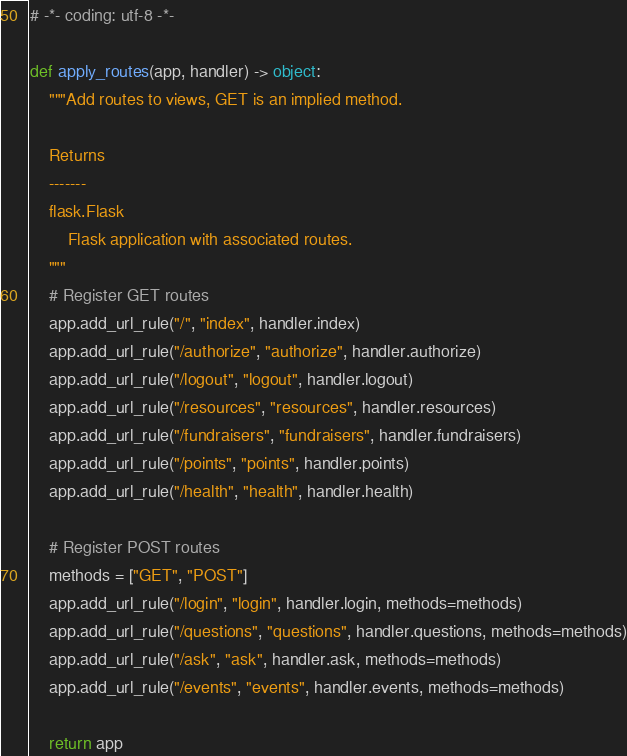<code> <loc_0><loc_0><loc_500><loc_500><_Python_># -*- coding: utf-8 -*-

def apply_routes(app, handler) -> object:
	"""Add routes to views, GET is an implied method.
	
	Returns
	-------
	flask.Flask
		Flask application with associated routes.
	"""
	# Register GET routes
	app.add_url_rule("/", "index", handler.index)
	app.add_url_rule("/authorize", "authorize", handler.authorize)
	app.add_url_rule("/logout", "logout", handler.logout)
	app.add_url_rule("/resources", "resources", handler.resources)
	app.add_url_rule("/fundraisers", "fundraisers", handler.fundraisers)
	app.add_url_rule("/points", "points", handler.points)
	app.add_url_rule("/health", "health", handler.health)

	# Register POST routes
	methods = ["GET", "POST"]
	app.add_url_rule("/login", "login", handler.login, methods=methods)
	app.add_url_rule("/questions", "questions", handler.questions, methods=methods)
	app.add_url_rule("/ask", "ask", handler.ask, methods=methods)
	app.add_url_rule("/events", "events", handler.events, methods=methods)
	
	return app</code> 